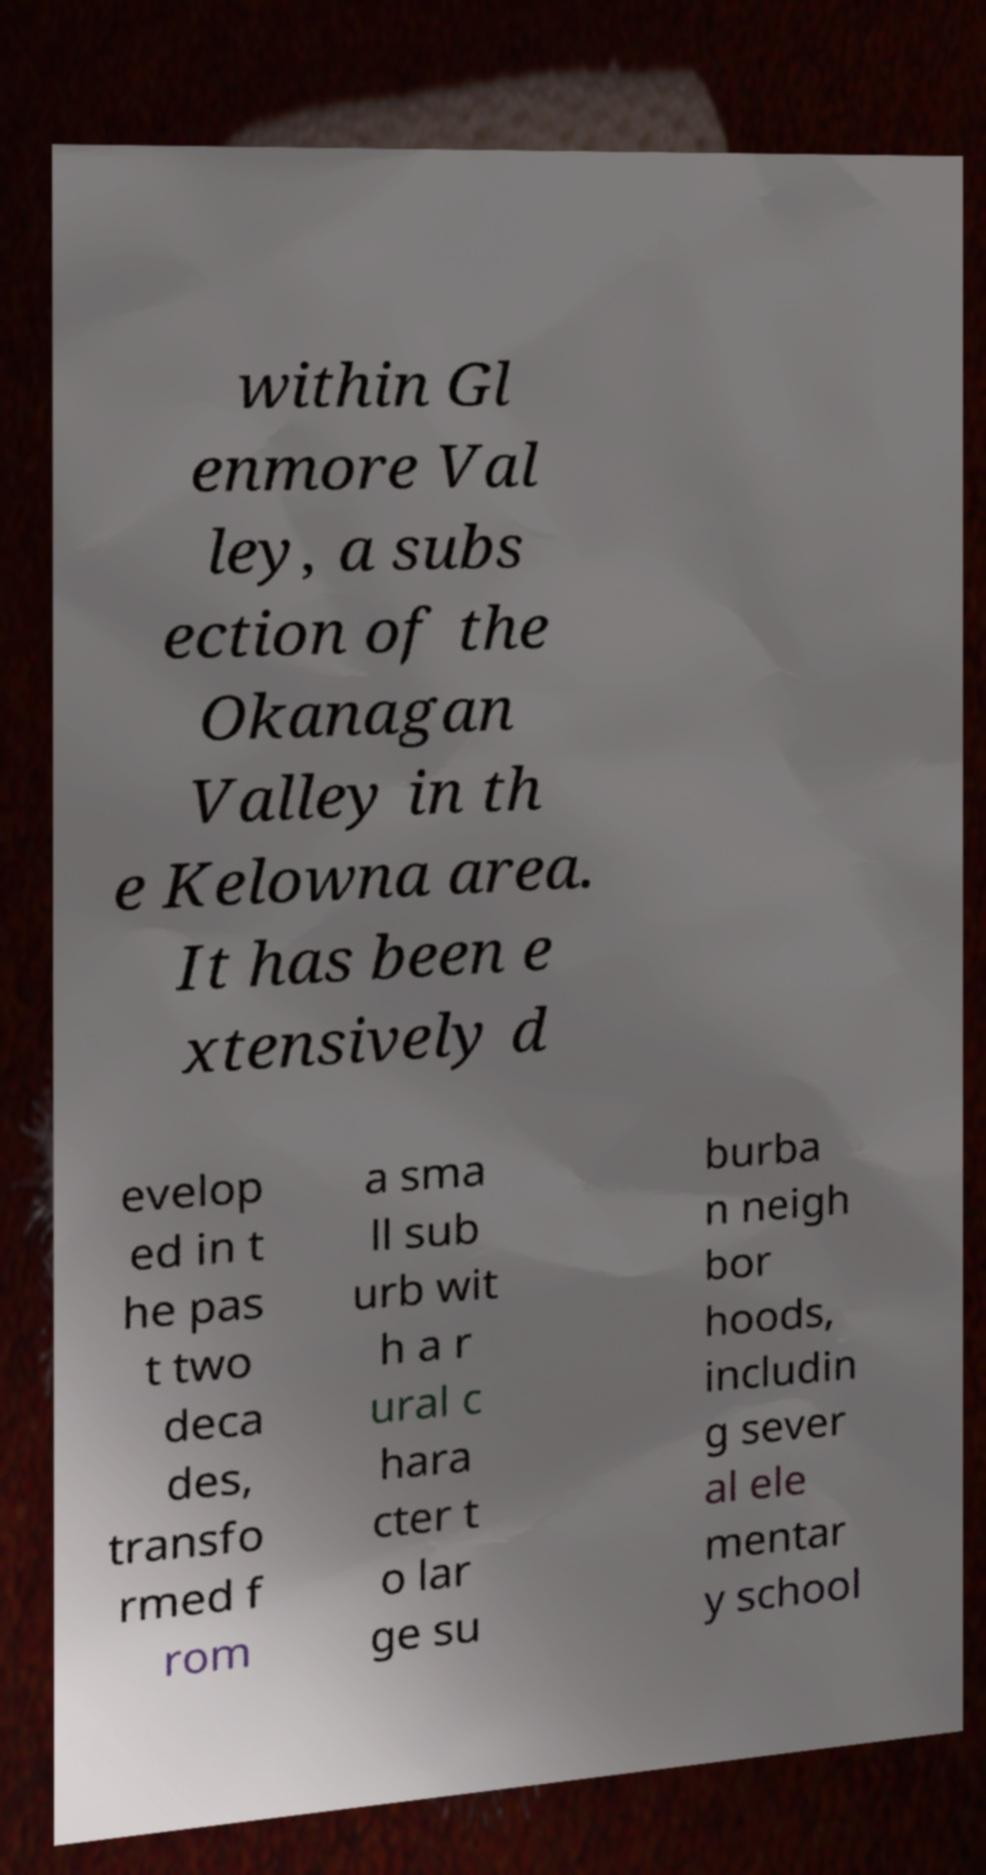For documentation purposes, I need the text within this image transcribed. Could you provide that? within Gl enmore Val ley, a subs ection of the Okanagan Valley in th e Kelowna area. It has been e xtensively d evelop ed in t he pas t two deca des, transfo rmed f rom a sma ll sub urb wit h a r ural c hara cter t o lar ge su burba n neigh bor hoods, includin g sever al ele mentar y school 